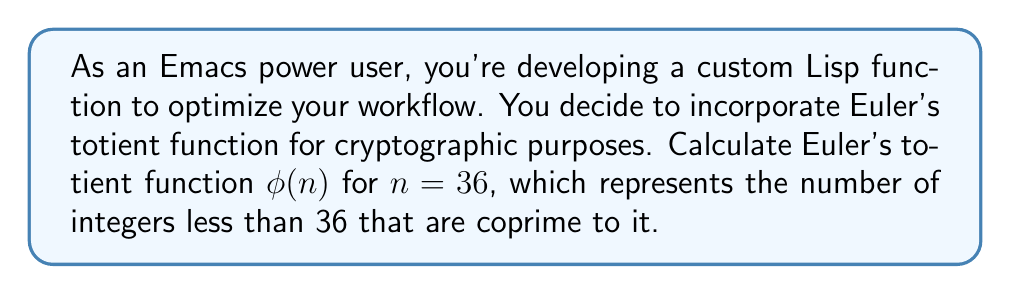Teach me how to tackle this problem. To calculate Euler's totient function $\phi(36)$, we'll follow these steps:

1) First, factorize 36 into its prime factors:
   $36 = 2^2 \times 3^2$

2) The general formula for Euler's totient function is:
   $$\phi(n) = n \prod_{p|n} (1 - \frac{1}{p})$$
   where $p$ are the distinct prime factors of $n$.

3) For $n = 36$, we have two distinct prime factors: 2 and 3. Let's apply the formula:

   $$\phi(36) = 36 \times (1 - \frac{1}{2}) \times (1 - \frac{1}{3})$$

4) Simplify:
   $$\phi(36) = 36 \times \frac{1}{2} \times \frac{2}{3}$$

5) Calculate:
   $$\phi(36) = 36 \times \frac{1}{3} = 12$$

Therefore, there are 12 integers less than 36 that are coprime to it.
Answer: $\phi(36) = 12$ 